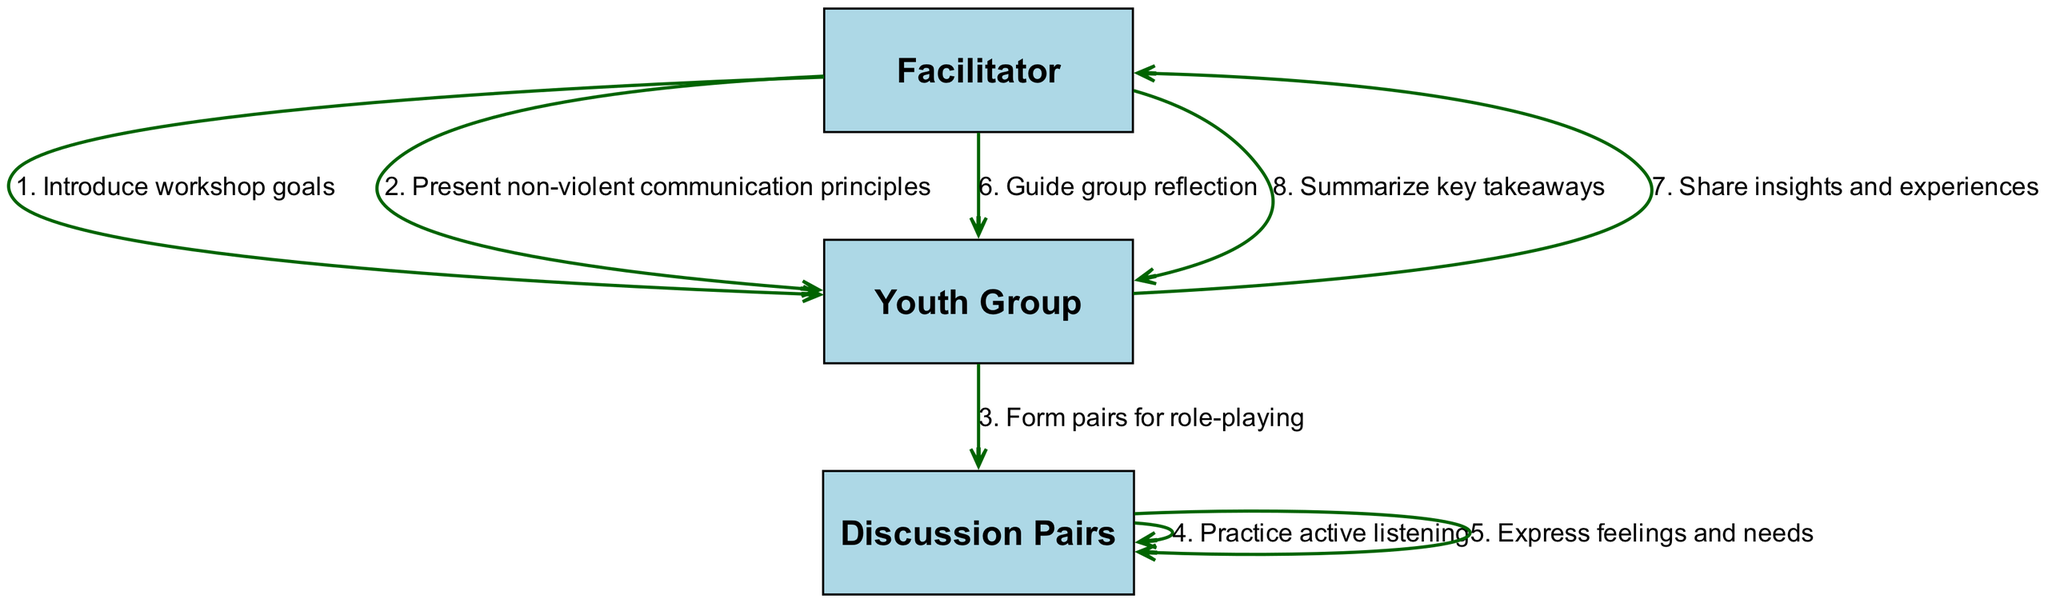What is the first action in the sequence? The first action in the sequence is to "Introduce workshop goals," which comes directly from the Facilitator to the Youth Group.
Answer: Introduce workshop goals How many participants are involved in the workshop? The participants listed in the diagram are Facilitator, Youth Group, and Discussion Pairs, making a total of three.
Answer: 3 What action comes after "Form pairs for role-playing"? The action that follows "Form pairs for role-playing" is "Practice active listening," which involves the Discussion Pairs interacting with each other.
Answer: Practice active listening Who shares insights and experiences with whom? The Youth Group shares insights and experiences with the Facilitator, as indicated by the arrow in the diagram.
Answer: Youth Group with Facilitator What is the last action in the sequence? The last action in the sequence is to "Summarize key takeaways," which is performed by the Facilitator to the Youth Group.
Answer: Summarize key takeaways How many actions are performed in total? There are a total of eight actions performed in the sequence as recorded in the sequence list of the diagram.
Answer: 8 Which participant guides the group reflection? The Facilitator is responsible for guiding the group reflection, as stated in the action sequence.
Answer: Facilitator What type of question does the sequence answer? The sequence answers questions about the steps involved in a non-violent conflict resolution workshop, demonstrating the flow of interactions among participants.
Answer: Sequence of events in the workshop 